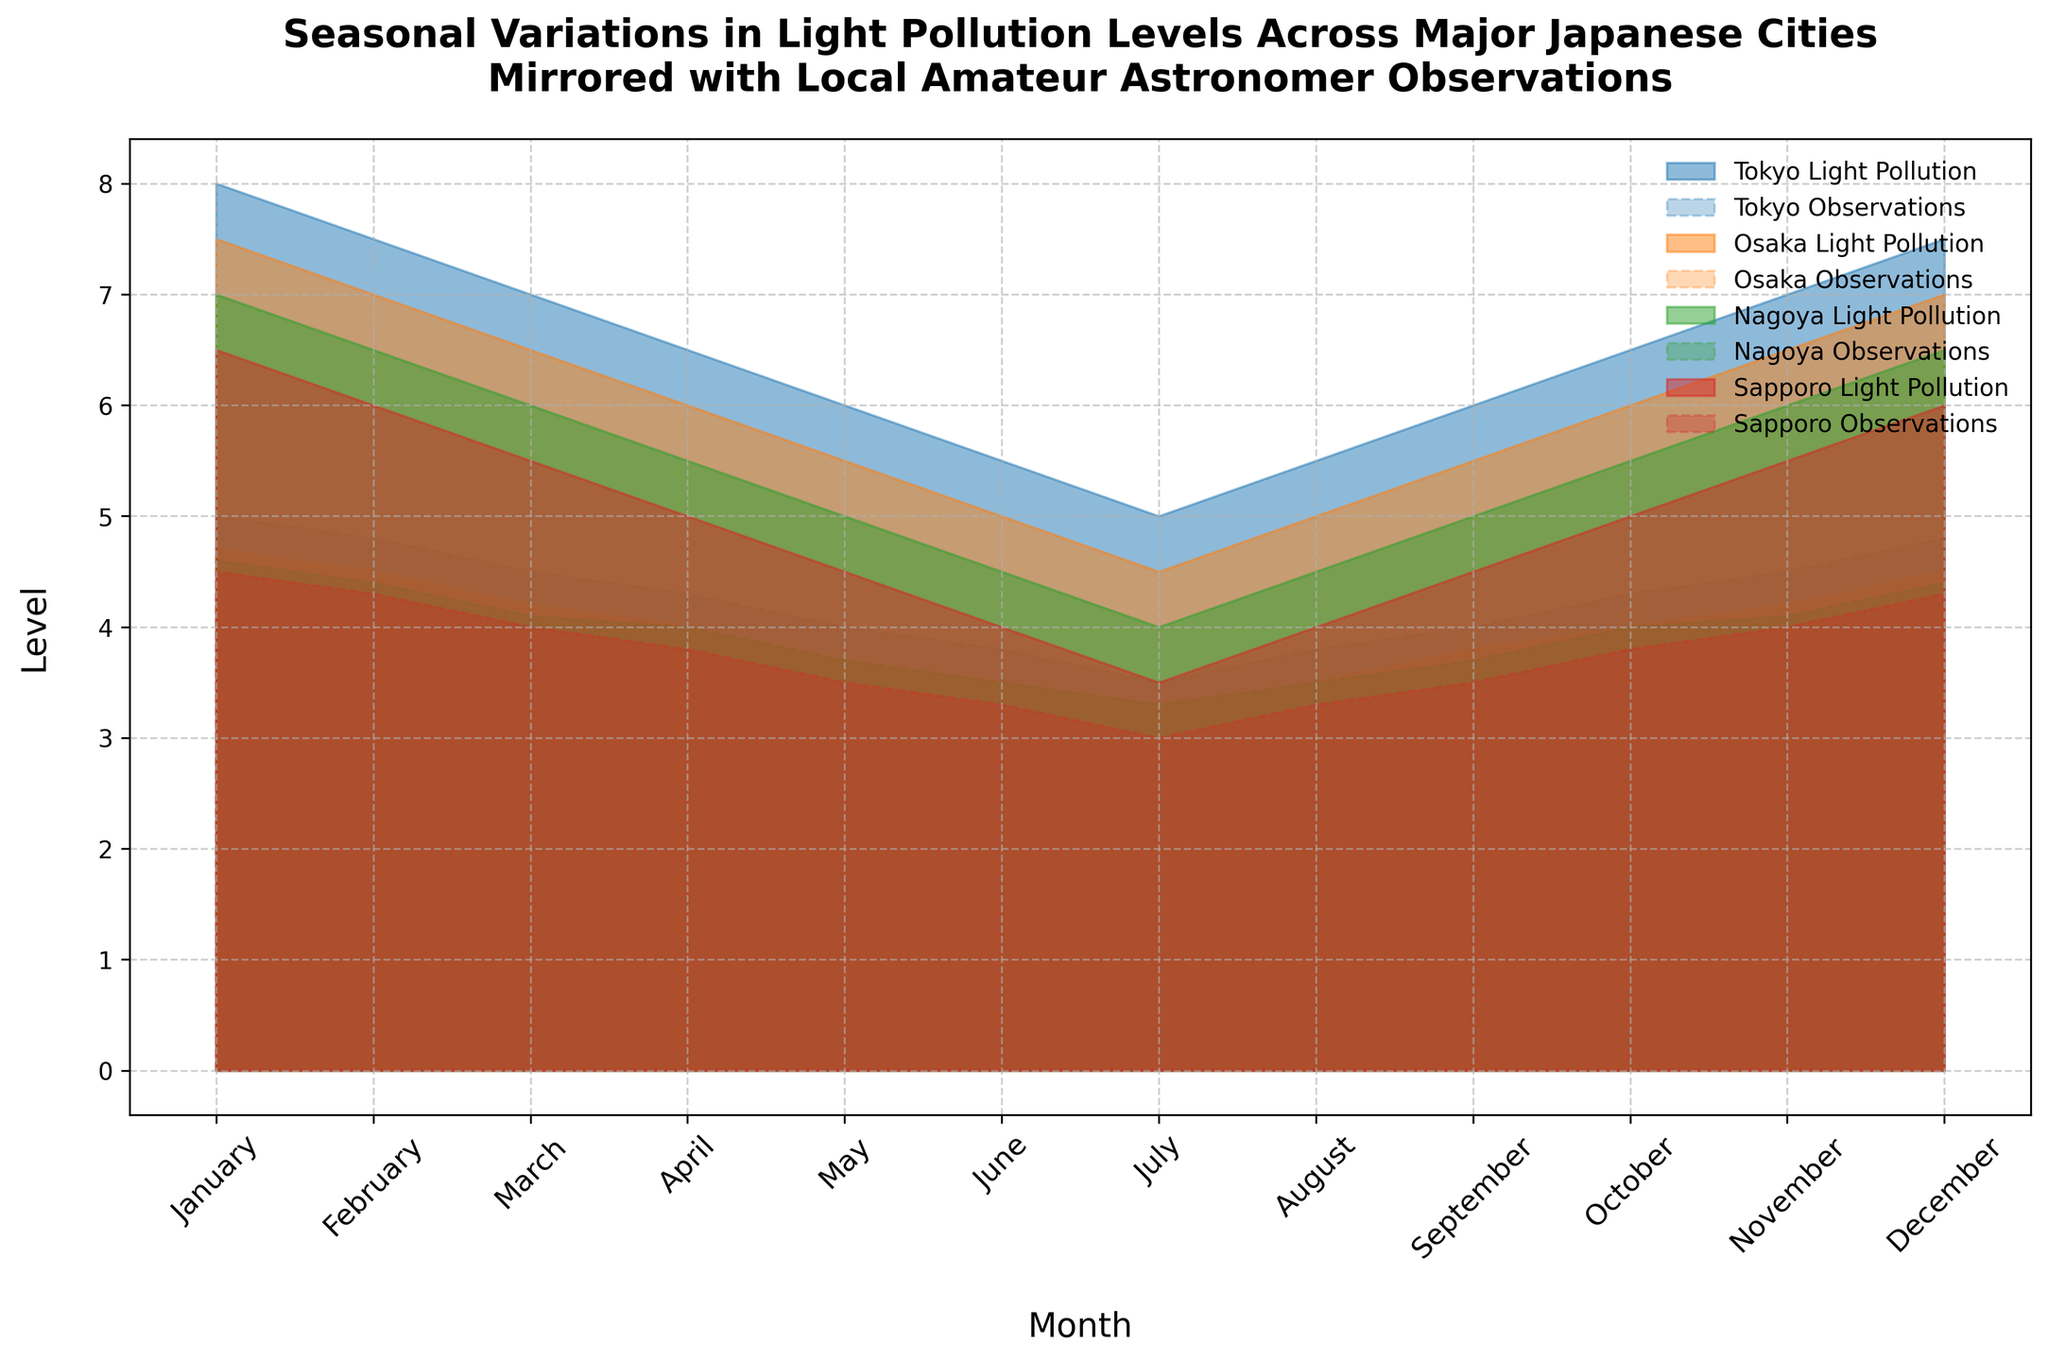Which city has the lowest light pollution level in May? To determine the lowest light pollution level in May, we check the figure and compare the values of the four cities: Tokyo, Osaka, Nagoya, and Sapporo. Tokyo has 6, Osaka has 5.5, Nagoya has 5, and Sapporo has 4.5.
Answer: Sapporo In which month does Tokyo have the highest light pollution level? We need to observe the light pollution levels for each month in Tokyo from January to December. The highest level is in January with a value of 8.
Answer: January How does the light pollution level in Nagoya in July compare to that of Osaka in the same month? We compare the values for Nagoya and Osaka in July. Nagoya has a light pollution level of 4, while Osaka has 4.5.
Answer: Nagoya is lower What is the difference in astronomer observations between Sapporo in January and Nagoya in November? We check Sapporo's observations in January (4.5) and Nagoya's in November (4.1). The difference is 4.5 - 4.1.
Answer: 0.4 During which months does Tokyo show a decreasing trend in light pollution? We observe the trend in Tokyo's light pollution levels from January to December. The levels decrease from January (8) to July (5), indicating a decreasing trend.
Answer: January to July Which city has the most consistent (least variable) light pollution levels throughout the year? We observe the variations for each city across the months. We notice that Nagoya's light pollution levels have very small monthly variations compared to the other cities.
Answer: Nagoya What visual pattern do the light pollution and astronomer observation levels in Sapporo show together? We look at the filled areas for Sapporo. Both levels decrease towards mid-year (June, July) and then start increasing towards the year-end, forming a U-shape pattern.
Answer: U-shape In which month does Osaka have its lowest astronomer observation level? We need to find the month with the lowest astronomer observation in Osaka from January to December. The lowest is in July with a value of 3.3.
Answer: July How do astronomer observations in Tokyo correlate with light pollution throughout the year? We compare the light pollution and astronomer observations lines. As light pollution decreases, astronomer observations also decrease, showing a positive correlation.
Answer: Positive correlation 